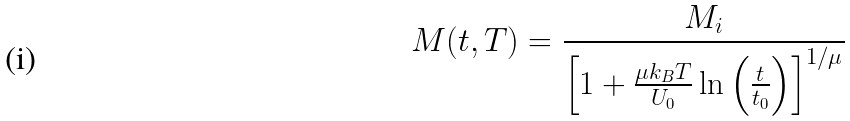Convert formula to latex. <formula><loc_0><loc_0><loc_500><loc_500>M ( t , T ) = \frac { M _ { i } } { \left [ 1 + \frac { \mu k _ { B } T } { U _ { 0 } } \ln \left ( \frac { t } { t _ { 0 } } \right ) \right ] ^ { 1 / \mu } }</formula> 